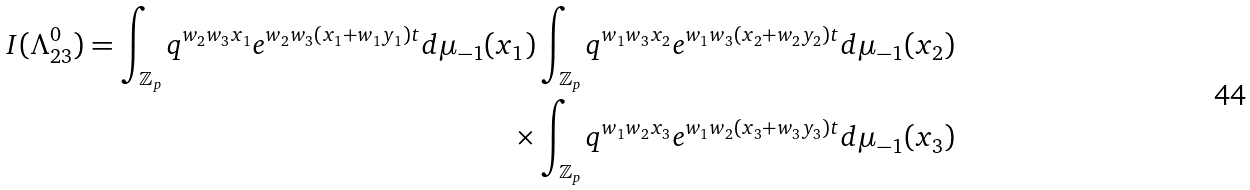Convert formula to latex. <formula><loc_0><loc_0><loc_500><loc_500>I ( \Lambda _ { 2 3 } ^ { 0 } ) = \int _ { \mathbb { Z } _ { p } } q ^ { w _ { 2 } w _ { 3 } x _ { 1 } } e ^ { w _ { 2 } w _ { 3 } ( x _ { 1 } + w _ { 1 } y _ { 1 } ) t } d \mu _ { - 1 } ( x _ { 1 } ) & \int _ { \mathbb { Z } _ { p } } q ^ { w _ { 1 } w _ { 3 } x _ { 2 } } e ^ { w _ { 1 } w _ { 3 } ( x _ { 2 } + w _ { 2 } y _ { 2 } ) t } d \mu _ { - 1 } ( x _ { 2 } ) \quad \\ \times & \int _ { \mathbb { Z } _ { p } } q ^ { w _ { 1 } w _ { 2 } x _ { 3 } } e ^ { w _ { 1 } w _ { 2 } ( x _ { 3 } + w _ { 3 } y _ { 3 } ) t } d \mu _ { - 1 } ( x _ { 3 } ) \\</formula> 